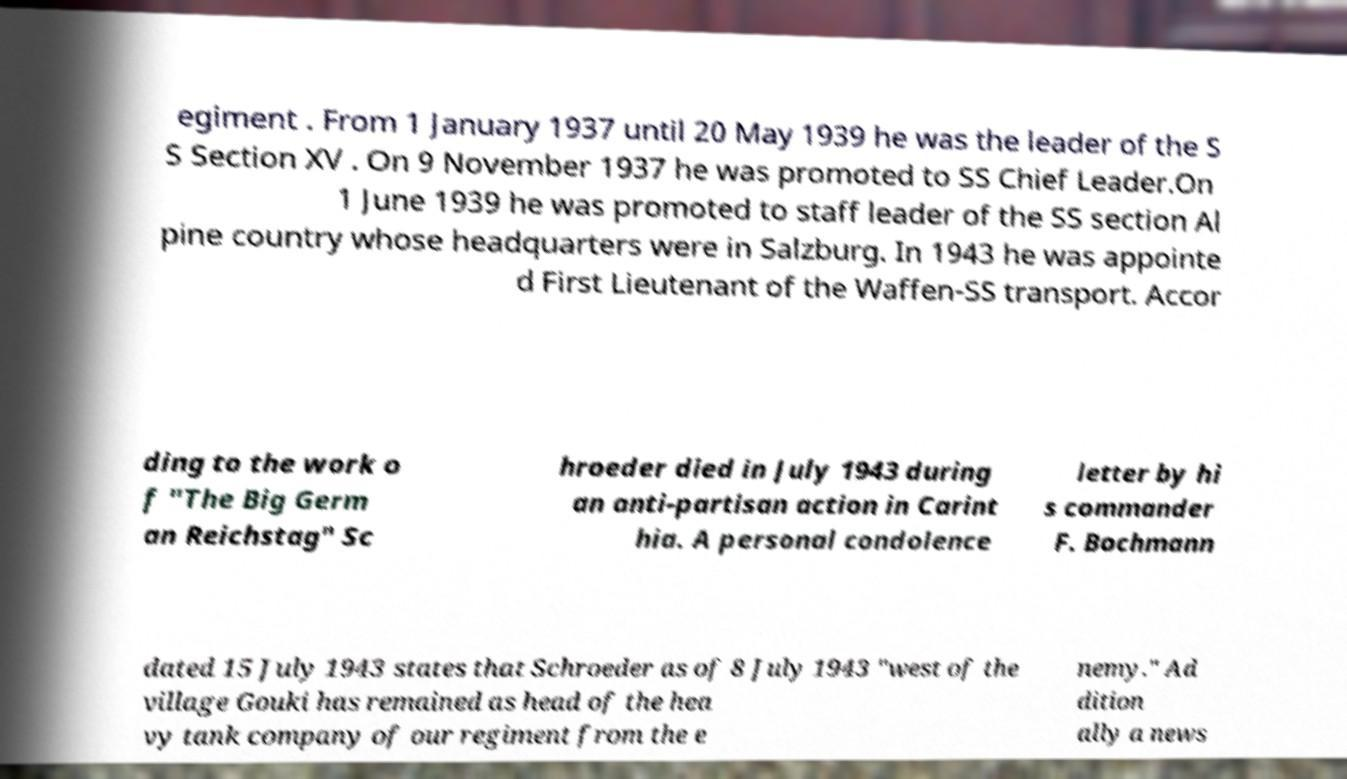Could you extract and type out the text from this image? egiment . From 1 January 1937 until 20 May 1939 he was the leader of the S S Section XV . On 9 November 1937 he was promoted to SS Chief Leader.On 1 June 1939 he was promoted to staff leader of the SS section Al pine country whose headquarters were in Salzburg. In 1943 he was appointe d First Lieutenant of the Waffen-SS transport. Accor ding to the work o f "The Big Germ an Reichstag" Sc hroeder died in July 1943 during an anti-partisan action in Carint hia. A personal condolence letter by hi s commander F. Bochmann dated 15 July 1943 states that Schroeder as of 8 July 1943 "west of the village Gouki has remained as head of the hea vy tank company of our regiment from the e nemy." Ad dition ally a news 